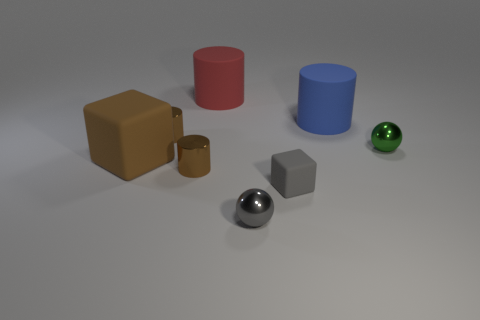Add 1 large red things. How many objects exist? 9 Subtract all balls. How many objects are left? 6 Subtract all large green metal objects. Subtract all cylinders. How many objects are left? 4 Add 1 green spheres. How many green spheres are left? 2 Add 6 green shiny cubes. How many green shiny cubes exist? 6 Subtract 1 brown cylinders. How many objects are left? 7 